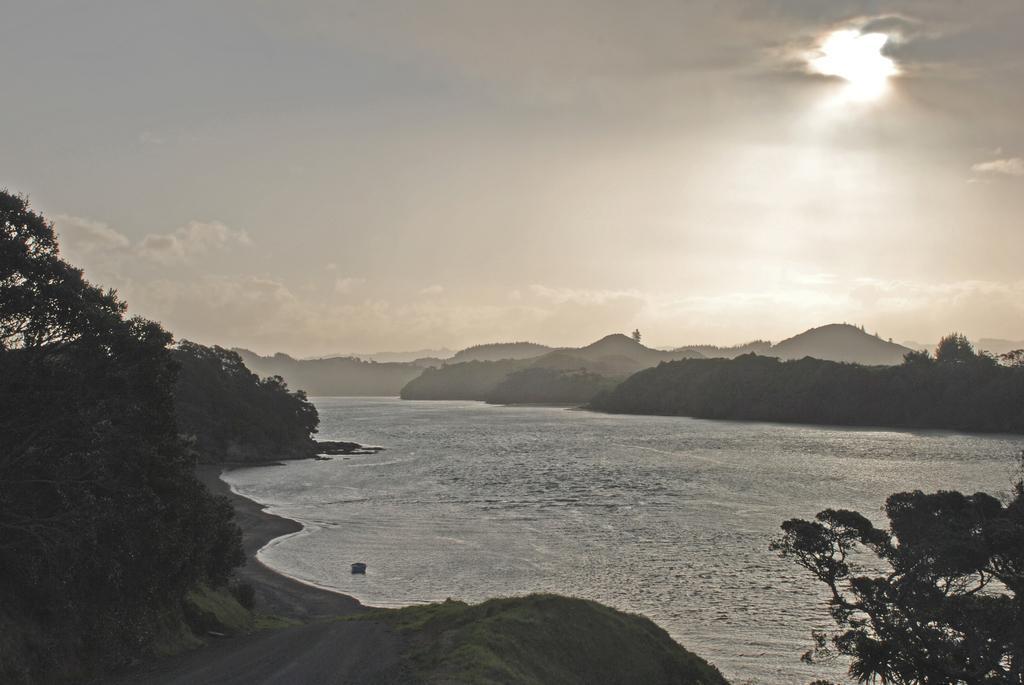How would you summarize this image in a sentence or two? This picture is clicked outside the city. In the center there is a water body. On the left we can see the trees and the plants. In the background there is a sky and the hills. 